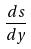Convert formula to latex. <formula><loc_0><loc_0><loc_500><loc_500>\frac { d s } { d y }</formula> 